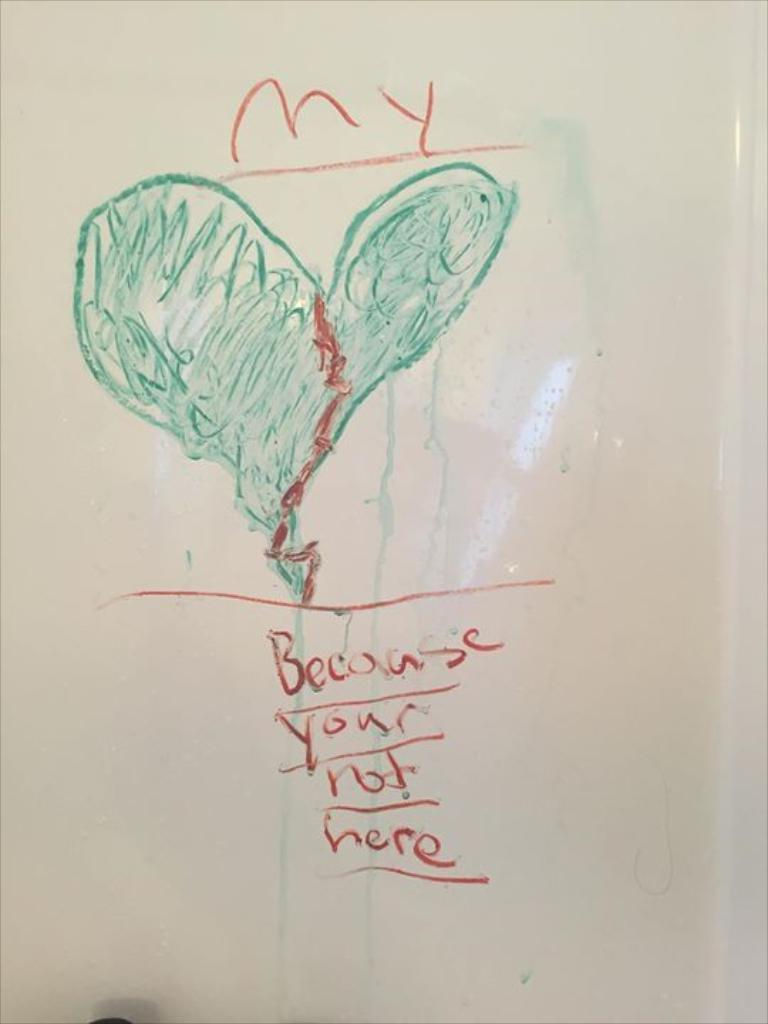Provide a one-sentence caption for the provided image. A drawn image of a heat on a white board that says, 'because your not here'. 